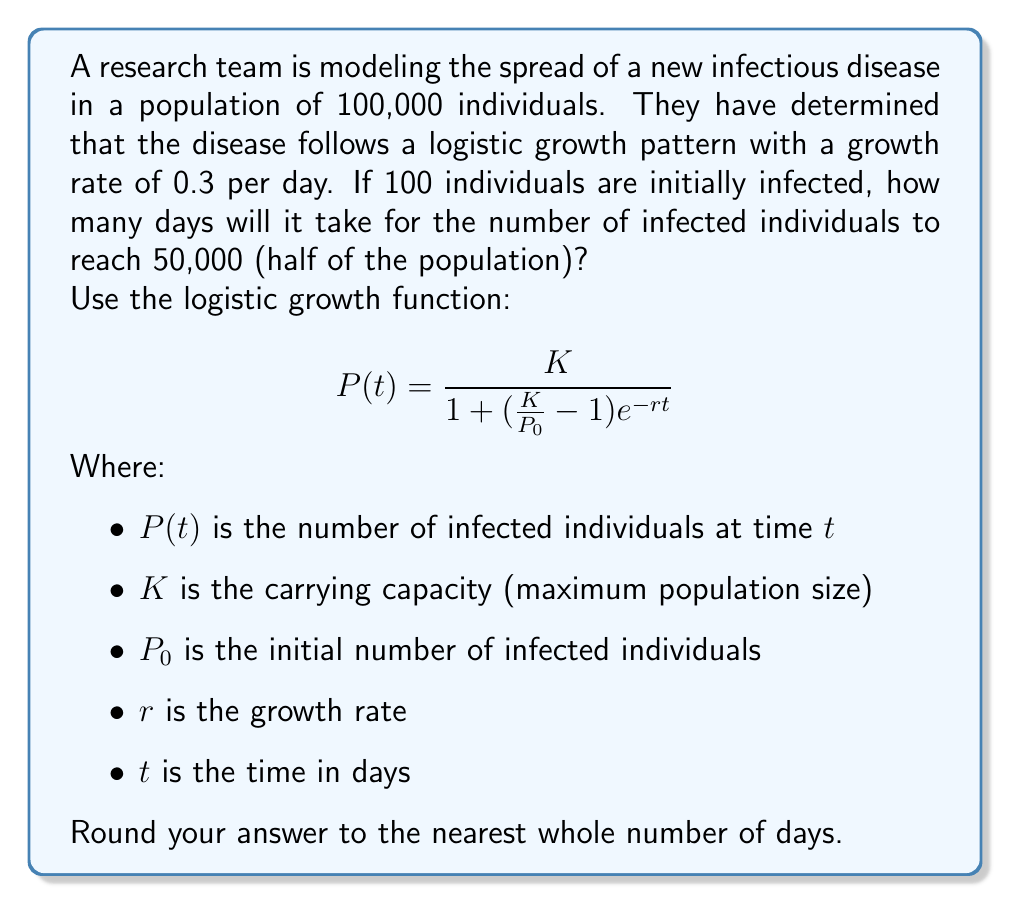Can you solve this math problem? To solve this problem, we'll use the logistic growth function and solve for $t$. Here's a step-by-step approach:

1. Identify the given values:
   $K = 100,000$ (carrying capacity)
   $P_0 = 100$ (initial infected)
   $r = 0.3$ (growth rate per day)
   $P(t) = 50,000$ (target infected population)

2. Substitute these values into the logistic growth function:

   $$50,000 = \frac{100,000}{1 + (\frac{100,000}{100} - 1)e^{-0.3t}}$$

3. Simplify the equation:

   $$50,000 = \frac{100,000}{1 + 999e^{-0.3t}}$$

4. Multiply both sides by the denominator:

   $$50,000(1 + 999e^{-0.3t}) = 100,000$$

5. Distribute on the left side:

   $$50,000 + 49,950,000e^{-0.3t} = 100,000$$

6. Subtract 50,000 from both sides:

   $$49,950,000e^{-0.3t} = 50,000$$

7. Divide both sides by 49,950,000:

   $$e^{-0.3t} = \frac{1}{999}$$

8. Take the natural logarithm of both sides:

   $$-0.3t = \ln(\frac{1}{999}) = -\ln(999)$$

9. Solve for $t$:

   $$t = \frac{\ln(999)}{0.3}$$

10. Calculate the result:

    $$t \approx 23.026$$

11. Round to the nearest whole number:

    $t = 23$ days
Answer: 23 days 